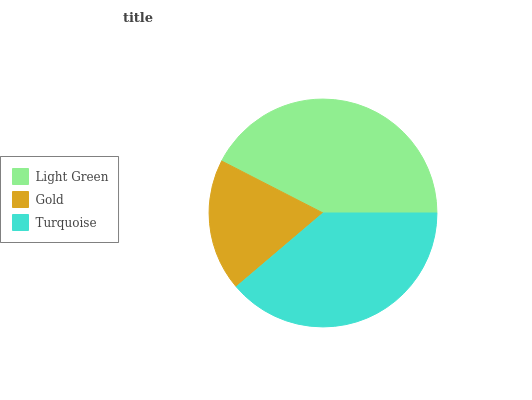Is Gold the minimum?
Answer yes or no. Yes. Is Light Green the maximum?
Answer yes or no. Yes. Is Turquoise the minimum?
Answer yes or no. No. Is Turquoise the maximum?
Answer yes or no. No. Is Turquoise greater than Gold?
Answer yes or no. Yes. Is Gold less than Turquoise?
Answer yes or no. Yes. Is Gold greater than Turquoise?
Answer yes or no. No. Is Turquoise less than Gold?
Answer yes or no. No. Is Turquoise the high median?
Answer yes or no. Yes. Is Turquoise the low median?
Answer yes or no. Yes. Is Gold the high median?
Answer yes or no. No. Is Light Green the low median?
Answer yes or no. No. 